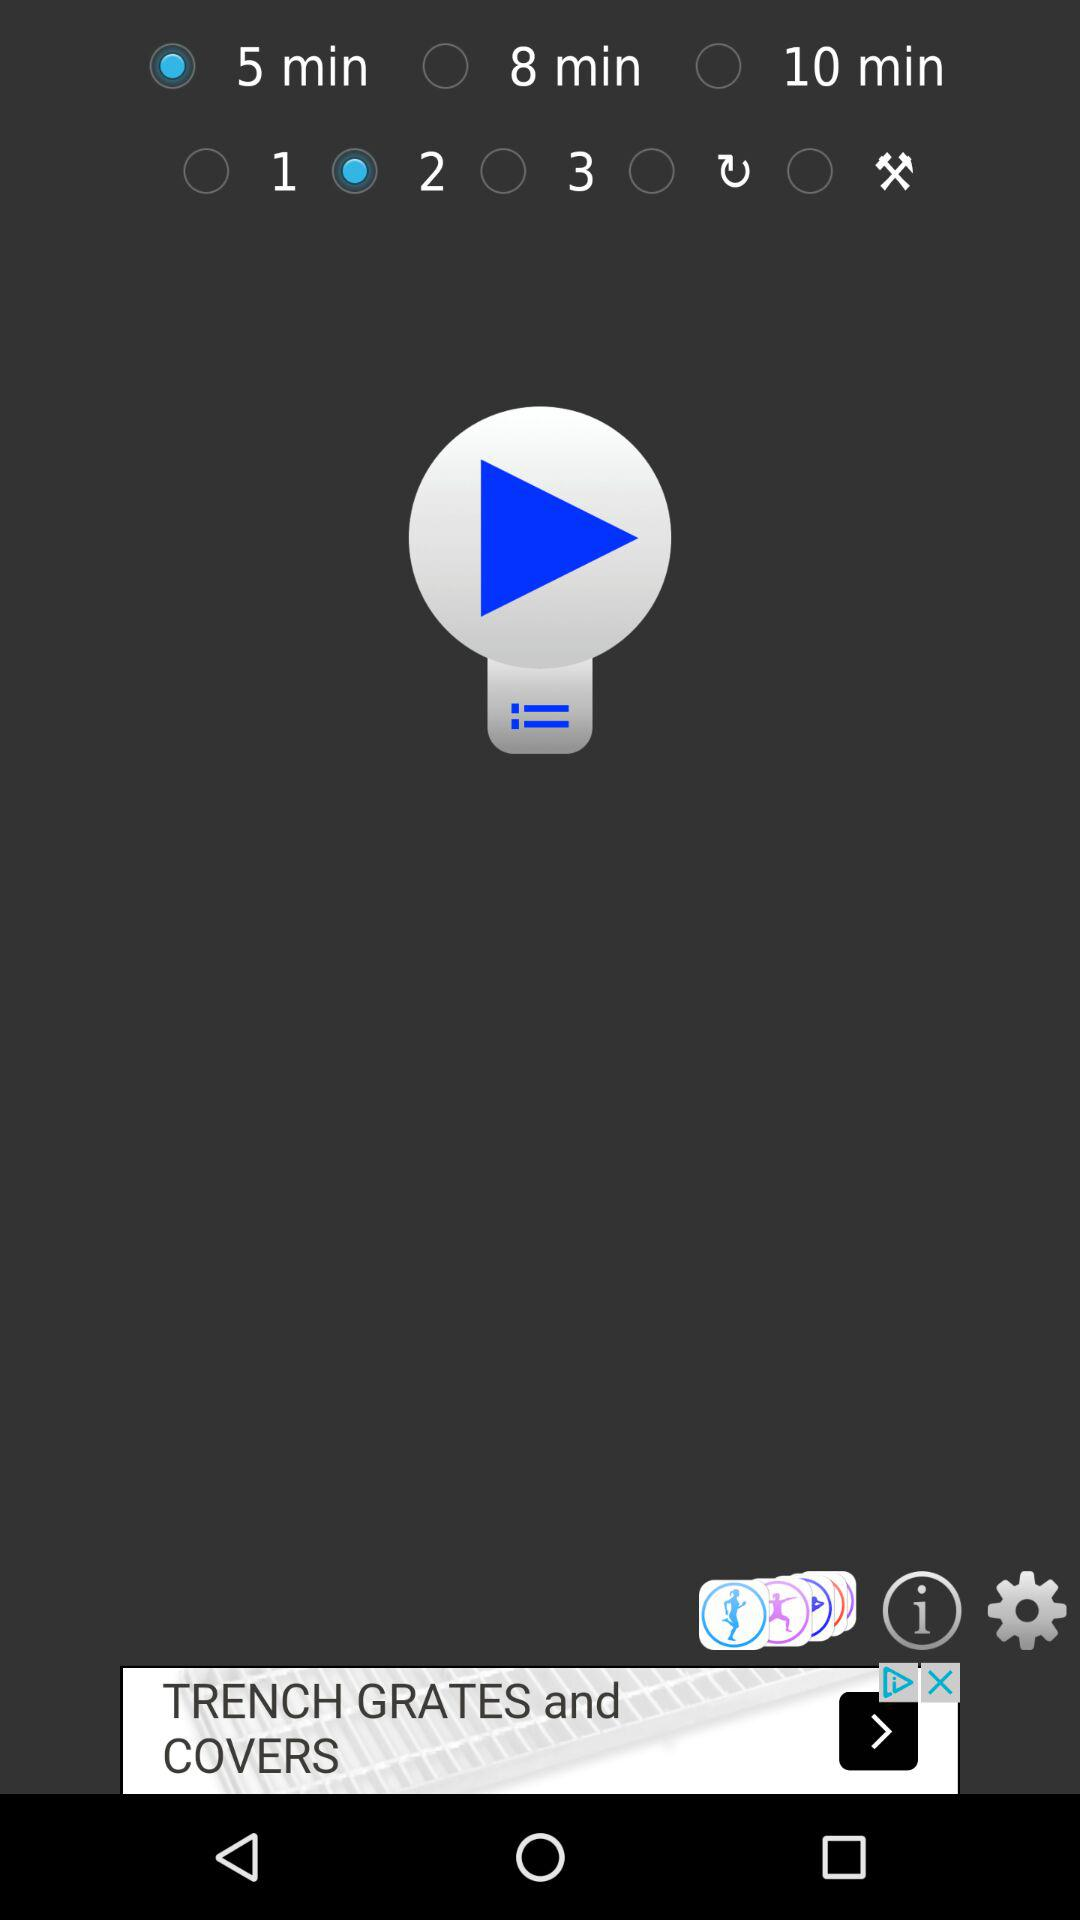How many more minutes are there in the 10 minute option than in the 5 minute option?
Answer the question using a single word or phrase. 5 